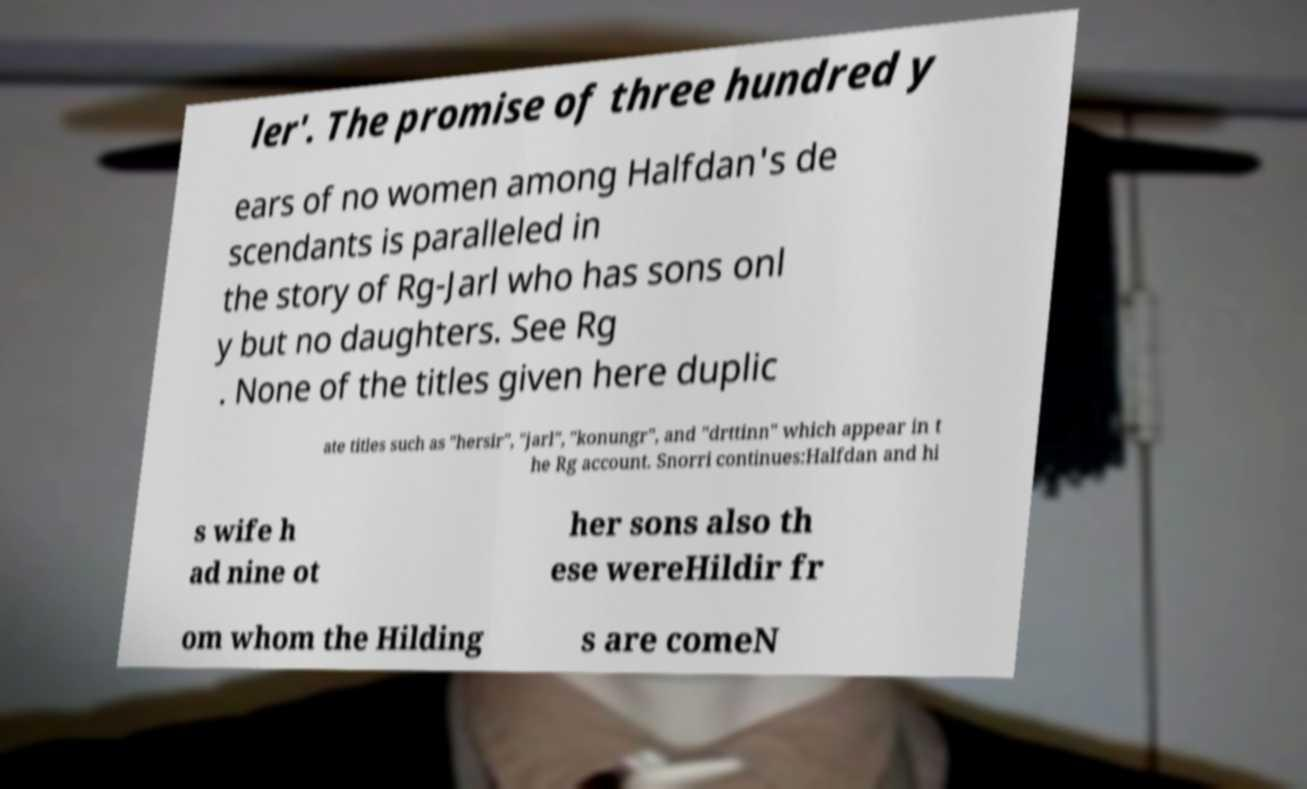There's text embedded in this image that I need extracted. Can you transcribe it verbatim? ler'. The promise of three hundred y ears of no women among Halfdan's de scendants is paralleled in the story of Rg-Jarl who has sons onl y but no daughters. See Rg . None of the titles given here duplic ate titles such as "hersir", "jarl", "konungr", and "drttinn" which appear in t he Rg account. Snorri continues:Halfdan and hi s wife h ad nine ot her sons also th ese wereHildir fr om whom the Hilding s are comeN 